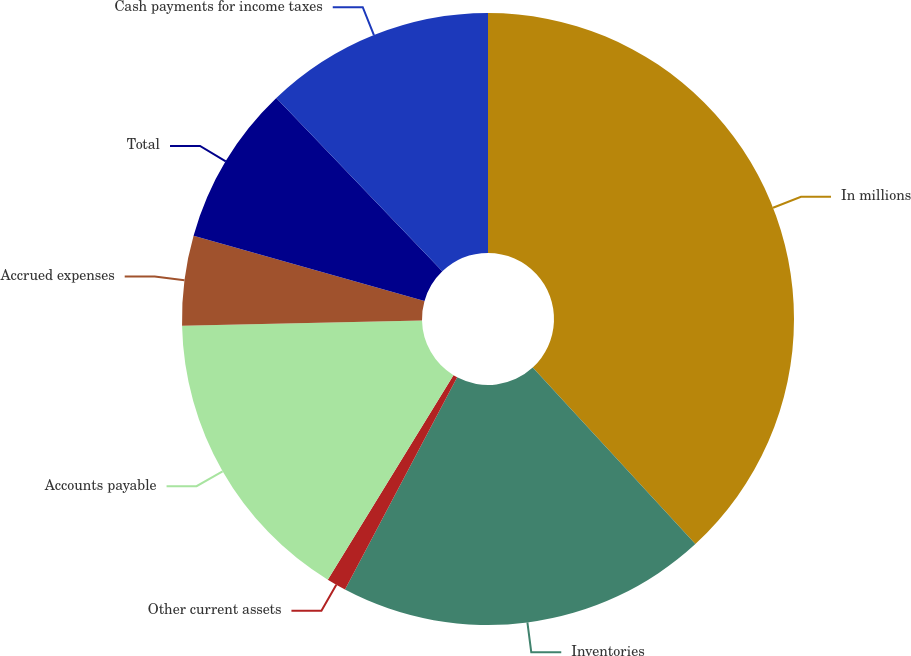Convert chart. <chart><loc_0><loc_0><loc_500><loc_500><pie_chart><fcel>In millions<fcel>Inventories<fcel>Other current assets<fcel>Accounts payable<fcel>Accrued expenses<fcel>Total<fcel>Cash payments for income taxes<nl><fcel>38.15%<fcel>19.59%<fcel>1.03%<fcel>15.88%<fcel>4.74%<fcel>8.45%<fcel>12.16%<nl></chart> 